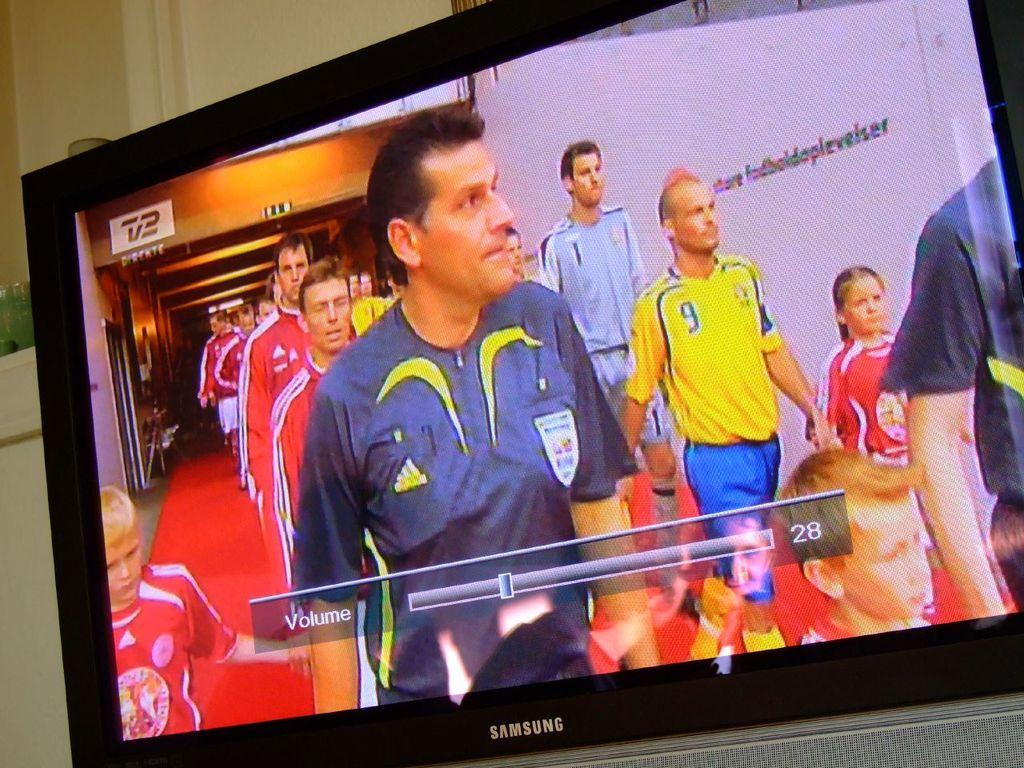<image>
Create a compact narrative representing the image presented. A bunch of people on the screen of a Samsung television. 